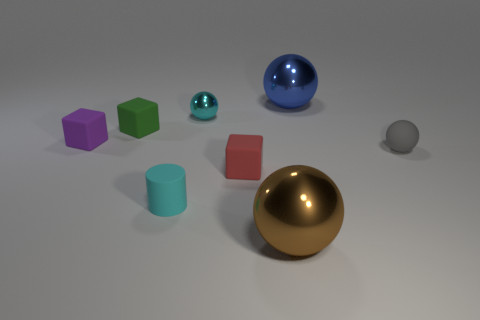Subtract all purple balls. Subtract all red cubes. How many balls are left? 4 Add 1 red rubber things. How many objects exist? 9 Subtract all cylinders. How many objects are left? 7 Add 4 blue shiny balls. How many blue shiny balls are left? 5 Add 4 gray shiny cylinders. How many gray shiny cylinders exist? 4 Subtract 0 brown cylinders. How many objects are left? 8 Subtract all green metallic balls. Subtract all purple rubber blocks. How many objects are left? 7 